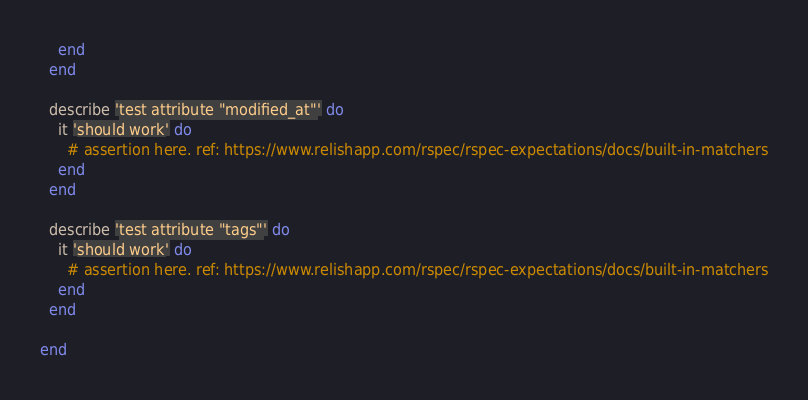Convert code to text. <code><loc_0><loc_0><loc_500><loc_500><_Ruby_>    end
  end

  describe 'test attribute "modified_at"' do
    it 'should work' do
      # assertion here. ref: https://www.relishapp.com/rspec/rspec-expectations/docs/built-in-matchers
    end
  end

  describe 'test attribute "tags"' do
    it 'should work' do
      # assertion here. ref: https://www.relishapp.com/rspec/rspec-expectations/docs/built-in-matchers
    end
  end

end
</code> 